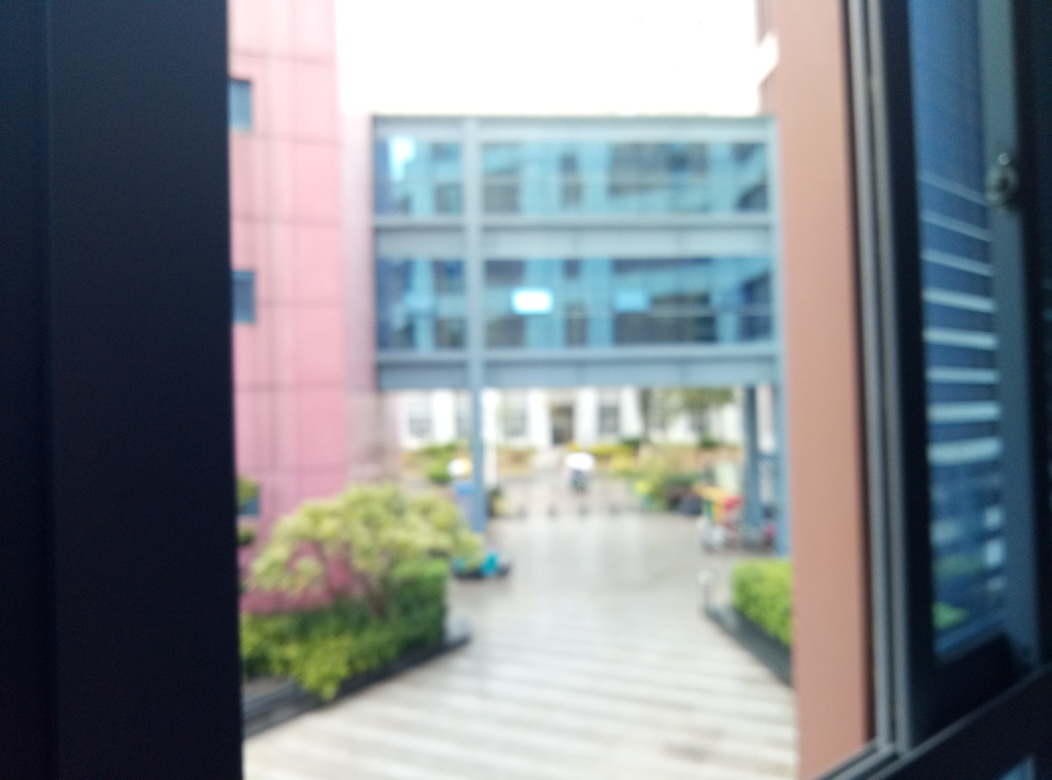Why does the sky appear bright in the image? Without conclusive evidence from the image alone, various factors could contribute to the sky's brightness, such as natural outdoor lighting conditions or camera exposure settings. An overexposed sky in this context might suggest that the camera's sensor captured more light in this region of the image than it could handle, leading to the bright appearance. Alternatively, if the day were naturally bright, and the camera properly calibrated, the sky might simply reflect those conditions. Adjusting camera settings to intentionally brighten the sky usually results in a high-key effect, which isn't apparent here. Based on the visible elements, the most probable reasons are a combination of a bright day and a slight overexposure caused by the camera's sensor settings not being ideally adjusted for the brightness levels. 